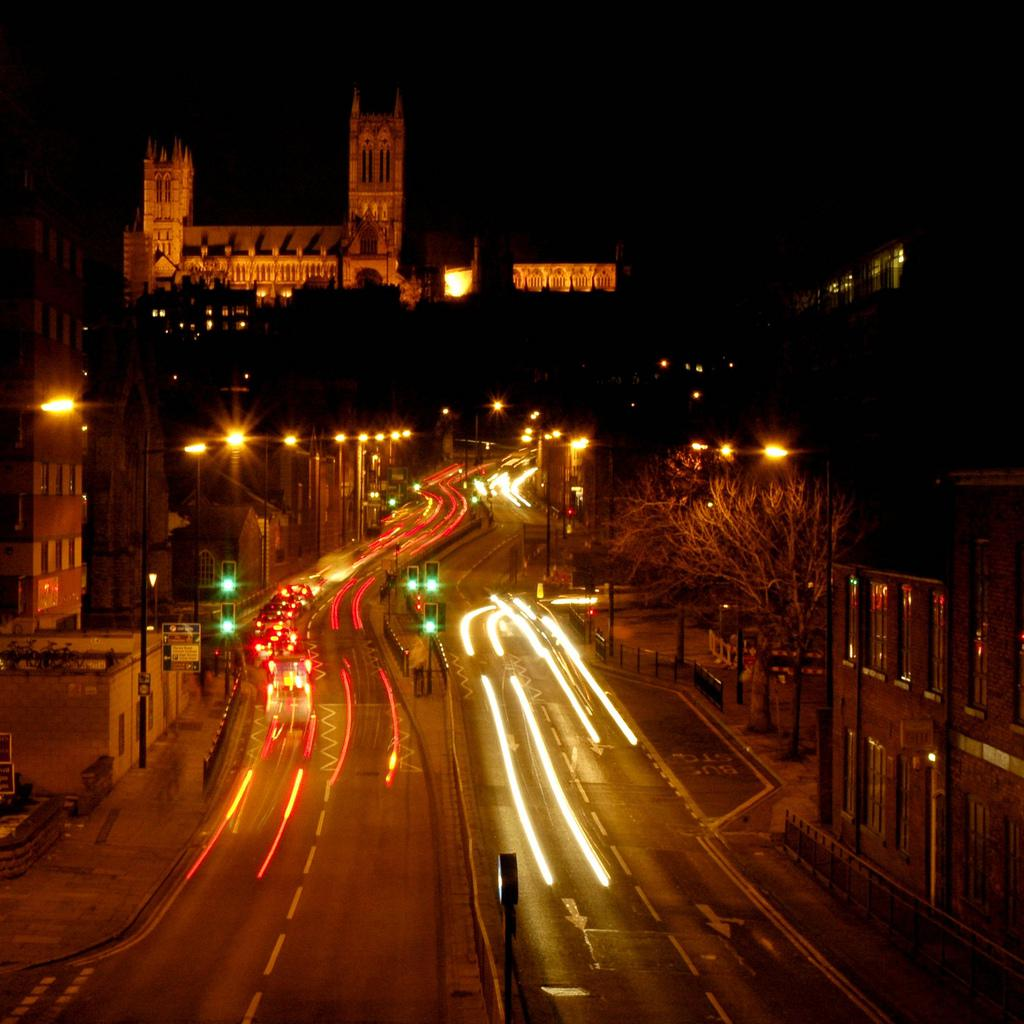Question: what color are the traffic lights?
Choices:
A. Green.
B. Red.
C. Yellow.
D. Orange.
Answer with the letter. Answer: A Question: what is in motion?
Choices:
A. The cars.
B. The train.
C. The bus.
D. The plane.
Answer with the letter. Answer: A Question: what type of road is this?
Choices:
A. Gravel.
B. A divided highway.
C. Paved.
D. Dirt.
Answer with the letter. Answer: B Question: what time of day is it?
Choices:
A. Noon.
B. Rush hour.
C. Morning.
D. Night.
Answer with the letter. Answer: D Question: where are there smaller buildings?
Choices:
A. In the back.
B. In the middle.
C. In the front.
D. Across the street.
Answer with the letter. Answer: C Question: what car lights are on?
Choices:
A. Hazards.
B. Rear lights and headlights.
C. Fog.
D. Brights.
Answer with the letter. Answer: B Question: where is there a place to pull off the road?
Choices:
A. The right side.
B. Rest stop in 2 miles.
C. Gas station.
D. Hotel.
Answer with the letter. Answer: A Question: when was this photo taken?
Choices:
A. Morning.
B. Early afternoon.
C. Nighttime.
D. Dusk.
Answer with the letter. Answer: C Question: how many total lanes of traffic are pictured?
Choices:
A. Two.
B. Four.
C. Three.
D. One.
Answer with the letter. Answer: B Question: how many traffic lights are shown in this photo?
Choices:
A. One.
B. Two.
C. Three.
D. Five.
Answer with the letter. Answer: D Question: what are the cars doing in this photograph?
Choices:
A. Driving.
B. Stopped at a light.
C. Going into the city.
D. Parking.
Answer with the letter. Answer: A Question: how many people are walking on sidewalk?
Choices:
A. Zero.
B. One.
C. Four.
D. Ten.
Answer with the letter. Answer: A Question: where are the church towers?
Choices:
A. By the bell tower.
B. Against the sky.
C. Downtown.
D. In the suburbs.
Answer with the letter. Answer: B Question: what color are the traffic lights?
Choices:
A. Green.
B. Yellow.
C. Red.
D. Blue.
Answer with the letter. Answer: A Question: what other kind of lights are there?
Choices:
A. Street lights.
B. Candle.
C. Lamp.
D. Moon.
Answer with the letter. Answer: A Question: how would you describe the trees?
Choices:
A. Bare.
B. Budding.
C. Flowering.
D. Drooping.
Answer with the letter. Answer: A Question: what are lights reflecting off of?
Choices:
A. The skyscraper.
B. The lake.
C. Windows.
D. The houses roof.
Answer with the letter. Answer: C Question: what color are the traffic lights?
Choices:
A. Green.
B. Yellow.
C. Red.
D. White.
Answer with the letter. Answer: A Question: what kind of photo is it?
Choices:
A. Black and white.
B. High-resolution.
C. Time lapse.
D. A snapshot.
Answer with the letter. Answer: C Question: what time of day is it?
Choices:
A. Noon.
B. Time to wake up.
C. Nighttime.
D. Evening.
Answer with the letter. Answer: C 